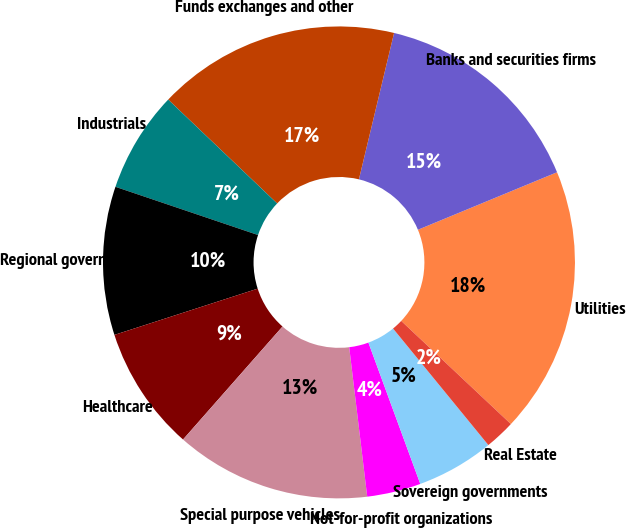Convert chart. <chart><loc_0><loc_0><loc_500><loc_500><pie_chart><fcel>Utilities<fcel>Banks and securities firms<fcel>Funds exchanges and other<fcel>Industrials<fcel>Regional governments<fcel>Healthcare<fcel>Special purpose vehicles<fcel>Not-for-profit organizations<fcel>Sovereign governments<fcel>Real Estate<nl><fcel>18.25%<fcel>15.01%<fcel>16.63%<fcel>6.93%<fcel>10.16%<fcel>8.54%<fcel>13.4%<fcel>3.69%<fcel>5.31%<fcel>2.08%<nl></chart> 